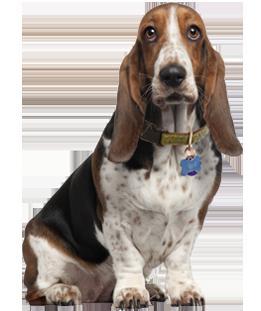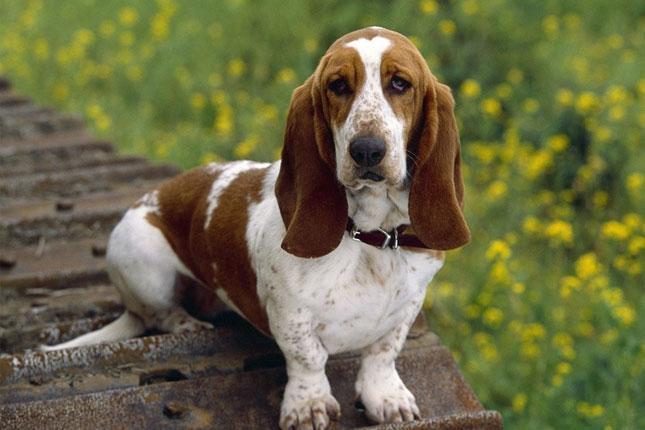The first image is the image on the left, the second image is the image on the right. For the images displayed, is the sentence "The left image shows a basset pup on green grass." factually correct? Answer yes or no. No. 